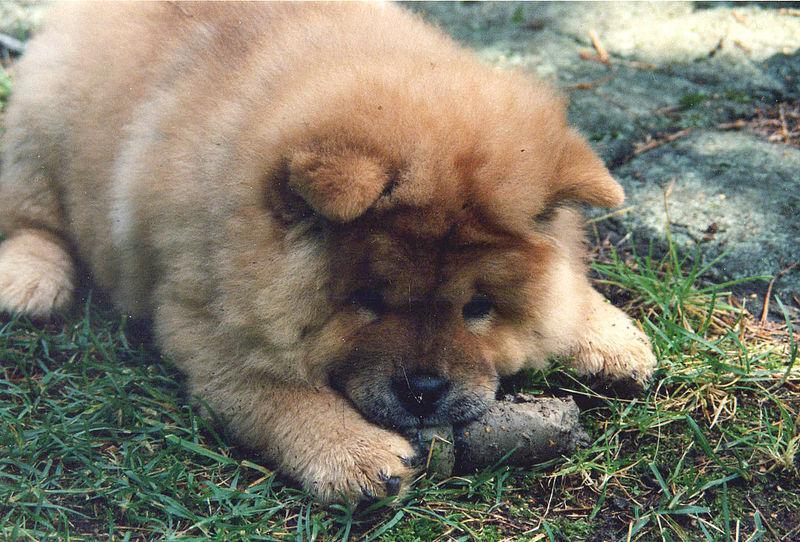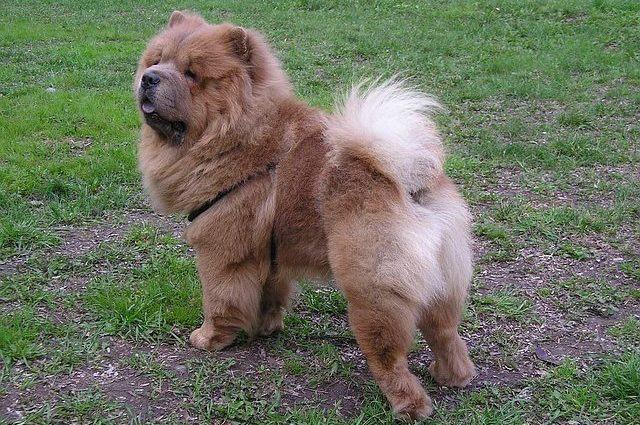The first image is the image on the left, the second image is the image on the right. Considering the images on both sides, is "The left image contains exactly one red-orange chow puppy, and the right image contains exactly one red-orange adult chow." valid? Answer yes or no. Yes. The first image is the image on the left, the second image is the image on the right. For the images shown, is this caption "There are just two dogs." true? Answer yes or no. Yes. 